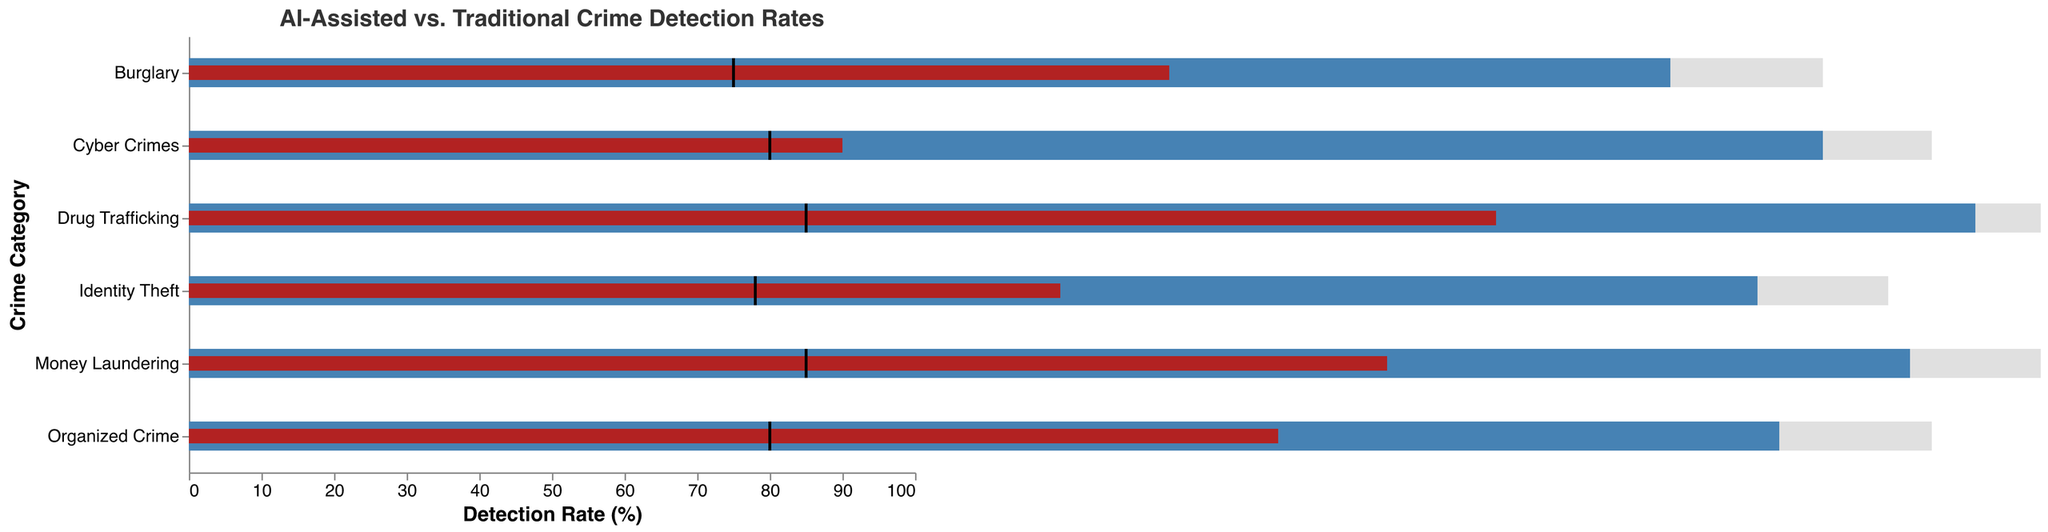What's the title of the chart? The title text is at the top of the chart and it reads "AI-Assisted vs. Traditional Crime Detection Rates"
Answer: AI-Assisted vs. Traditional Crime Detection Rates Which category has the lowest traditional detection rate? To find the lowest traditional detection rate, look at the red bars representing traditional detection rates. The category with the shortest red bar is Cyber Crimes at 30%.
Answer: Cyber Crimes What is the target detection rate for Money Laundering? The target detection rate is shown by the black tick marks on the chart. For Money Laundering, the black tick mark is positioned at 85%.
Answer: 85% How do the detection rates for Identity Theft compare between traditional and AI-assisted methods? Compare the length of the red bar for the traditional method and the blue bar for the AI-assisted method. The traditional method has a detection rate of 40%, and the AI-assisted method has a detection rate of 72%.
Answer: 40% vs. 72% Which crime category has the smallest gap between AI-assisted detection rate and the target? Calculate the difference between AI-assisted detection rate and the target for each category. The smallest difference is for Identity Theft (72% AI-assisted, 78% target), giving a gap of 6%.
Answer: Identity Theft How many categories have AI-assisted detection rates above 70%? Count the categories where the blue bars (AI-assisted detection rates) are above 70%. There are 5 categories: Burglary, Drug Trafficking, Cyber Crimes, Identity Theft, and Money Laundering.
Answer: 5 Which crime category shows the greatest improvement in detection rate with AI assistance? Calculate the difference between the AI-assisted and traditional detection rates for each category. The largest difference is for Cyber Crimes, with an improvement of 45% (75% - 30%).
Answer: Cyber Crimes What is the range of detection rates for Burglary across traditional, AI-assisted, and target values? The range is found by identifying the minimum and maximum rates for Burglary. Traditional is 45%, AI-assisted is 68%, and target is 75%. The range is 30% (75% - 45%).
Answer: 30% Is there any category where the AI-assisted detection rate does not meet the target? Compare the AI-assisted detection rates (blue bars) to the target rates (black tick marks). All categories have AI-assisted detection rates below their targets.
Answer: Yes 